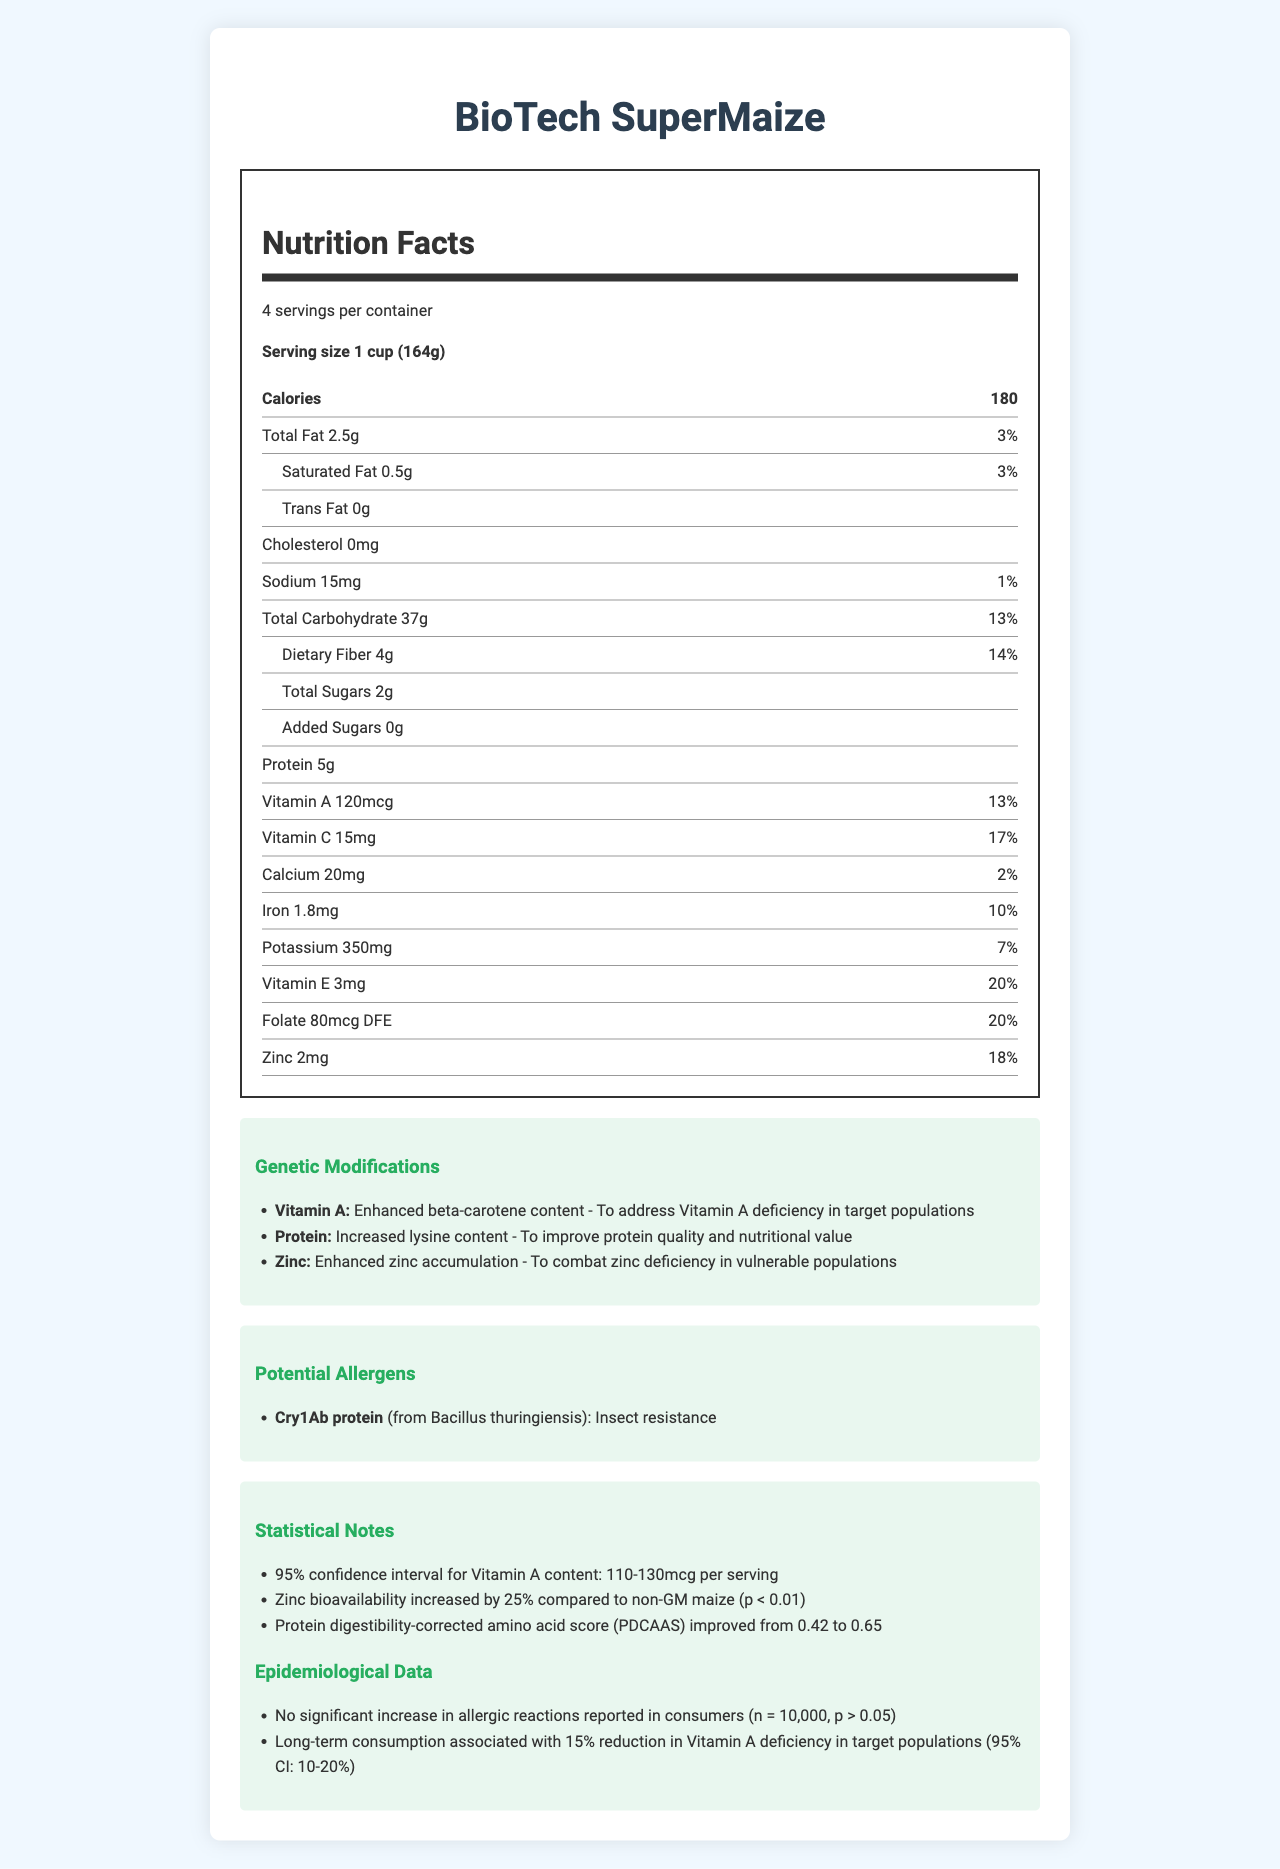What is the serving size for BioTech SuperMaize? The serving size is mentioned at the top under the product name and in the Nutrition Facts section.
Answer: 1 cup (164g) How many calories are in one serving of BioTech SuperMaize? The calorie content is listed under the bold section "Calories" in the Nutrition Facts.
Answer: 180 What is the daily value percentage of Vitamin C in one serving? The daily value percentage for Vitamin C is listed in the Nutrition Facts section.
Answer: 17% How much protein is in one serving of BioTech SuperMaize? The protein content is listed in the Nutrition Facts section.
Answer: 5g What is the main allergen mentioned for BioTech SuperMaize? The main allergen is mentioned in the Potential Allergens section.
Answer: Cry1Ab protein Which nutrient has an enhanced beta-carotene content due to genetic modification? A. Vitamin A B. Protein C. Zinc The Genetic Modifications section mentions that Vitamin A has enhanced beta-carotene content.
Answer: A What is the improved Protein Digestibility-Corrected Amino Acid Score (PDCAAS) for BioTech SuperMaize after genetic modification? A. 0.42 B. 0.52 C. 0.65 D. 0.75 The Statistical Notes section states that the PDCAAS improved from 0.42 to 0.65.
Answer: C Is there any cholesterol in BioTech SuperMaize? The Nutrition Facts section states that there is 0mg of cholesterol.
Answer: No Summarize the purpose of the genetic modifications in BioTech SuperMaize. The Genetic Modifications section describes enhancements in beta-carotene for Vitamin A, increased lysine for protein quality, and enhanced zinc accumulation to combat deficiencies.
Answer: To enhance vitamin and mineral content to address deficiencies and improve protein quality. What is the 95% confidence interval for Vitamin A content per serving? The confidence interval for Vitamin A content is mentioned in the Statistical Notes section.
Answer: 110-130mcg Has long-term consumption of BioTech SuperMaize been associated with a reduction in Vitamin A deficiency in target populations? The Epidemiological Data section states a 15% reduction in Vitamin A deficiency with a 95% confidence interval of 10-20%.
Answer: Yes What is the sodium content in one serving of BioTech SuperMaize? The sodium content is listed in the Nutrition Facts section.
Answer: 15mg Can we determine the exact percentage of consumers who reported allergic reactions to BioTech SuperMaize? The Epidemiological Data section mentions no significant increase in allergic reactions but does not provide the exact percentage.
Answer: No, not enough information How does BioTech SuperMaize compare in zinc bioavailability to non-GM maize? The Statistical Notes section states that zinc bioavailability increased by 25% compared to non-GM maize.
Answer: Increased by 25% 